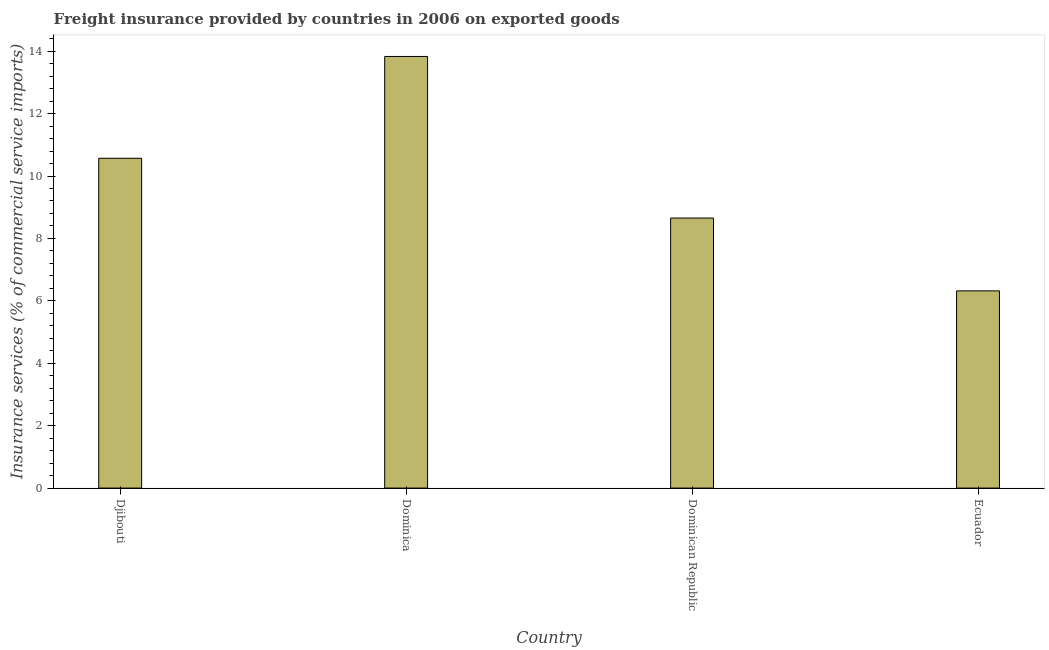Does the graph contain any zero values?
Provide a short and direct response. No. What is the title of the graph?
Your answer should be very brief. Freight insurance provided by countries in 2006 on exported goods . What is the label or title of the Y-axis?
Your answer should be very brief. Insurance services (% of commercial service imports). What is the freight insurance in Ecuador?
Your answer should be very brief. 6.32. Across all countries, what is the maximum freight insurance?
Your answer should be compact. 13.83. Across all countries, what is the minimum freight insurance?
Offer a very short reply. 6.32. In which country was the freight insurance maximum?
Offer a terse response. Dominica. In which country was the freight insurance minimum?
Your response must be concise. Ecuador. What is the sum of the freight insurance?
Ensure brevity in your answer.  39.37. What is the difference between the freight insurance in Dominican Republic and Ecuador?
Provide a succinct answer. 2.33. What is the average freight insurance per country?
Provide a short and direct response. 9.84. What is the median freight insurance?
Provide a short and direct response. 9.61. In how many countries, is the freight insurance greater than 4.4 %?
Your answer should be very brief. 4. What is the ratio of the freight insurance in Djibouti to that in Dominican Republic?
Your response must be concise. 1.22. Is the difference between the freight insurance in Dominican Republic and Ecuador greater than the difference between any two countries?
Keep it short and to the point. No. What is the difference between the highest and the second highest freight insurance?
Your answer should be compact. 3.26. What is the difference between the highest and the lowest freight insurance?
Offer a very short reply. 7.51. In how many countries, is the freight insurance greater than the average freight insurance taken over all countries?
Your answer should be compact. 2. What is the difference between two consecutive major ticks on the Y-axis?
Ensure brevity in your answer.  2. Are the values on the major ticks of Y-axis written in scientific E-notation?
Ensure brevity in your answer.  No. What is the Insurance services (% of commercial service imports) in Djibouti?
Provide a succinct answer. 10.57. What is the Insurance services (% of commercial service imports) of Dominica?
Your answer should be very brief. 13.83. What is the Insurance services (% of commercial service imports) in Dominican Republic?
Your response must be concise. 8.65. What is the Insurance services (% of commercial service imports) in Ecuador?
Ensure brevity in your answer.  6.32. What is the difference between the Insurance services (% of commercial service imports) in Djibouti and Dominica?
Provide a succinct answer. -3.26. What is the difference between the Insurance services (% of commercial service imports) in Djibouti and Dominican Republic?
Offer a very short reply. 1.91. What is the difference between the Insurance services (% of commercial service imports) in Djibouti and Ecuador?
Your answer should be very brief. 4.25. What is the difference between the Insurance services (% of commercial service imports) in Dominica and Dominican Republic?
Provide a short and direct response. 5.18. What is the difference between the Insurance services (% of commercial service imports) in Dominica and Ecuador?
Provide a short and direct response. 7.51. What is the difference between the Insurance services (% of commercial service imports) in Dominican Republic and Ecuador?
Ensure brevity in your answer.  2.33. What is the ratio of the Insurance services (% of commercial service imports) in Djibouti to that in Dominica?
Your answer should be compact. 0.76. What is the ratio of the Insurance services (% of commercial service imports) in Djibouti to that in Dominican Republic?
Provide a succinct answer. 1.22. What is the ratio of the Insurance services (% of commercial service imports) in Djibouti to that in Ecuador?
Your response must be concise. 1.67. What is the ratio of the Insurance services (% of commercial service imports) in Dominica to that in Dominican Republic?
Provide a succinct answer. 1.6. What is the ratio of the Insurance services (% of commercial service imports) in Dominica to that in Ecuador?
Ensure brevity in your answer.  2.19. What is the ratio of the Insurance services (% of commercial service imports) in Dominican Republic to that in Ecuador?
Make the answer very short. 1.37. 